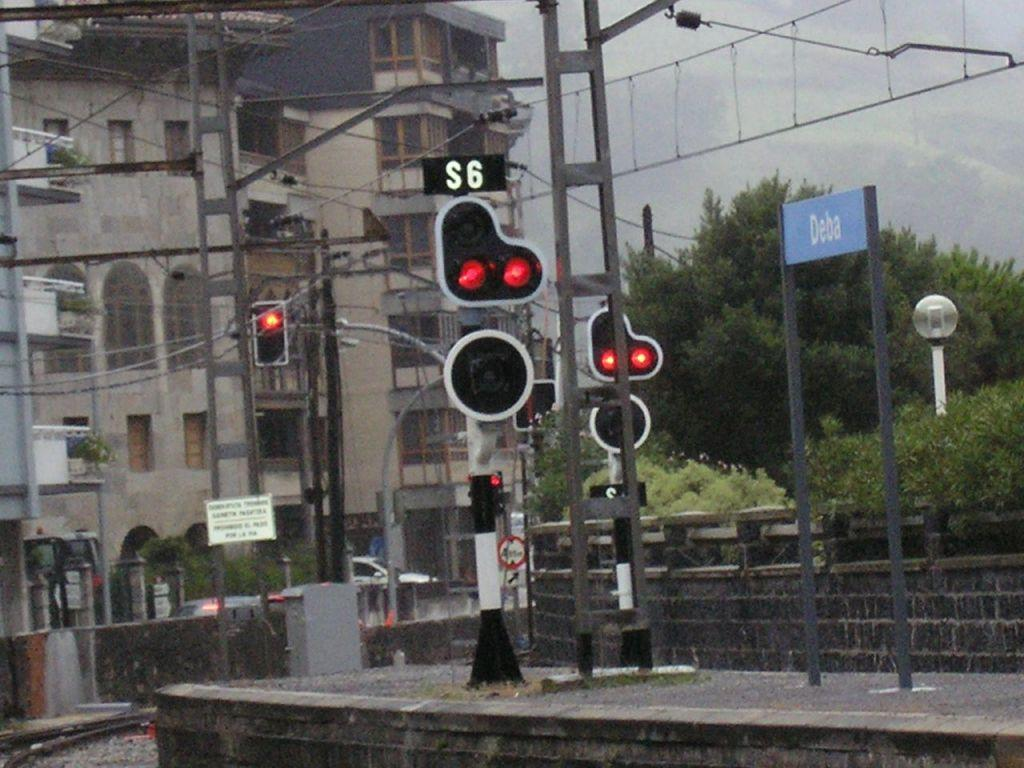Provide a one-sentence caption for the provided image. A complicated set of traffic lights are next to a blue sign reading Deba. 